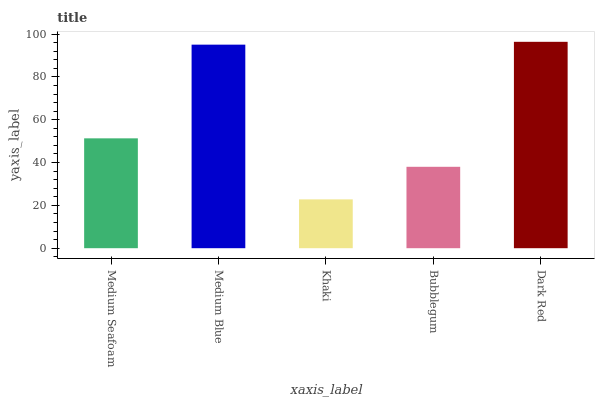Is Khaki the minimum?
Answer yes or no. Yes. Is Dark Red the maximum?
Answer yes or no. Yes. Is Medium Blue the minimum?
Answer yes or no. No. Is Medium Blue the maximum?
Answer yes or no. No. Is Medium Blue greater than Medium Seafoam?
Answer yes or no. Yes. Is Medium Seafoam less than Medium Blue?
Answer yes or no. Yes. Is Medium Seafoam greater than Medium Blue?
Answer yes or no. No. Is Medium Blue less than Medium Seafoam?
Answer yes or no. No. Is Medium Seafoam the high median?
Answer yes or no. Yes. Is Medium Seafoam the low median?
Answer yes or no. Yes. Is Medium Blue the high median?
Answer yes or no. No. Is Medium Blue the low median?
Answer yes or no. No. 